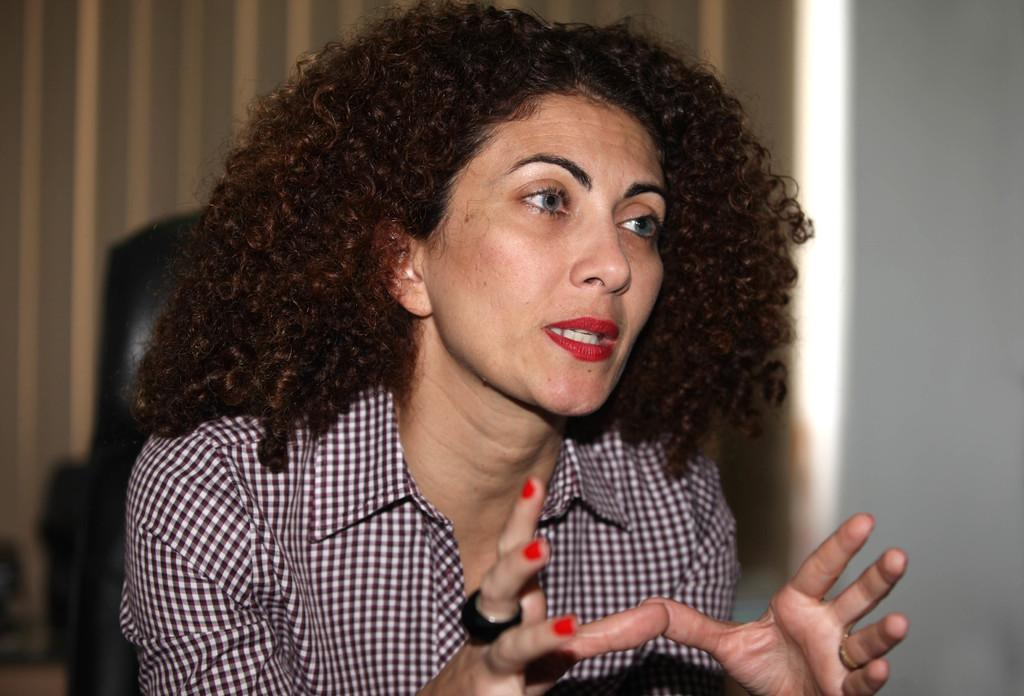Who is present in the image? There is a woman in the image. What is the woman wearing? The woman is wearing a shirt. Can you describe any accessories the woman is wearing? The woman has a ring on her finger. What can be seen in the background of the image? There is a curtain in the background of the image. What type of instrument is the woman playing in the image? There is no instrument present in the image, and the woman is not playing any instrument. 